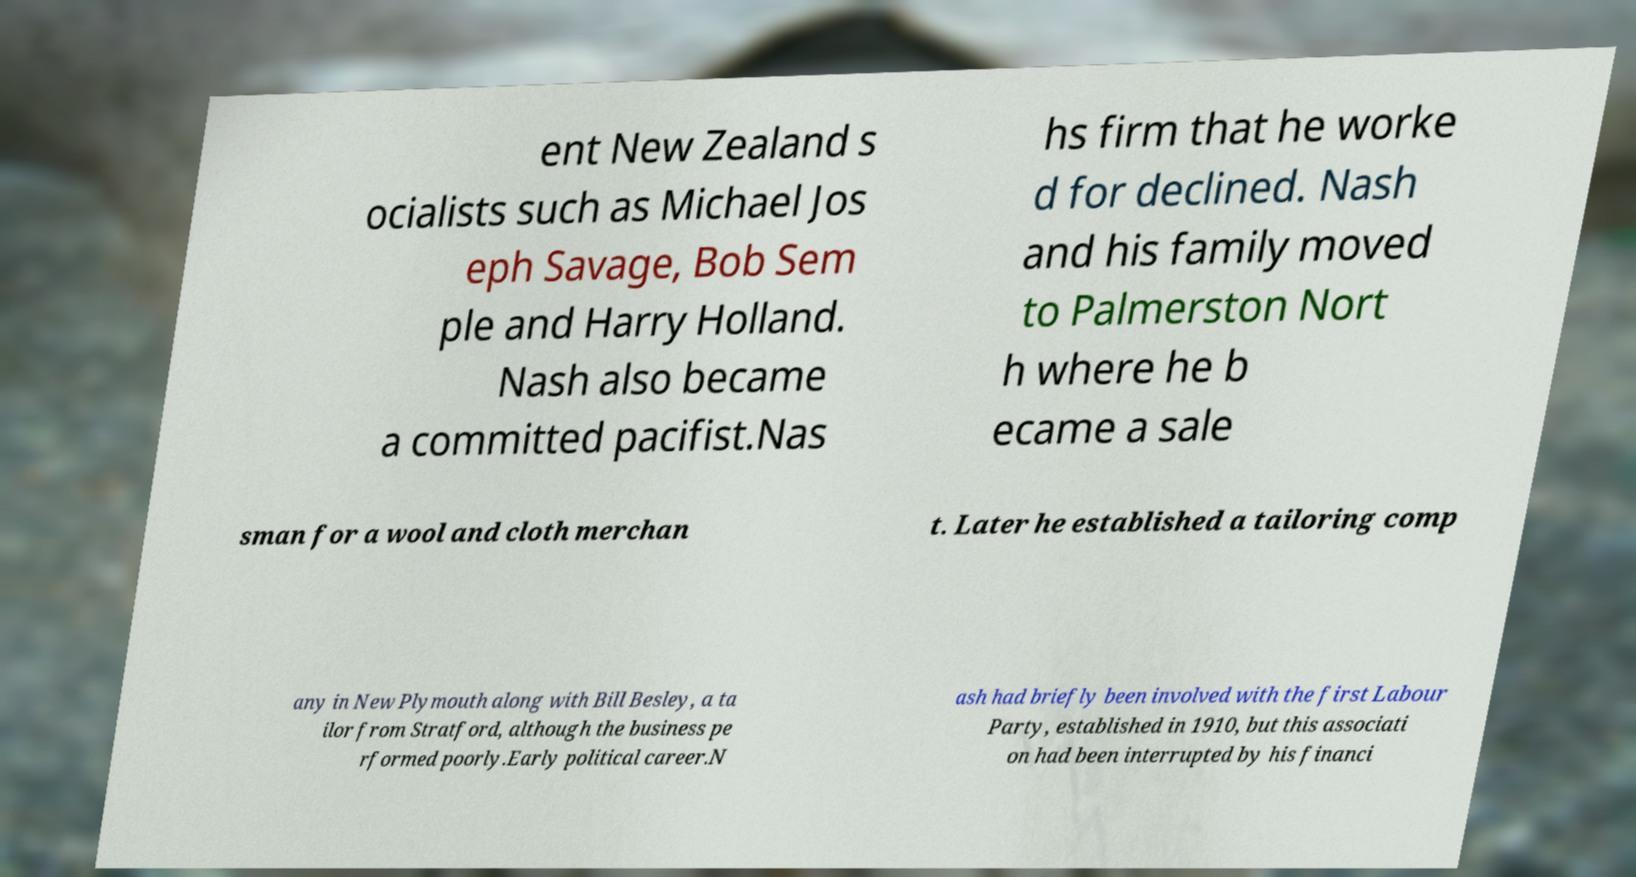Please read and relay the text visible in this image. What does it say? ent New Zealand s ocialists such as Michael Jos eph Savage, Bob Sem ple and Harry Holland. Nash also became a committed pacifist.Nas hs firm that he worke d for declined. Nash and his family moved to Palmerston Nort h where he b ecame a sale sman for a wool and cloth merchan t. Later he established a tailoring comp any in New Plymouth along with Bill Besley, a ta ilor from Stratford, although the business pe rformed poorly.Early political career.N ash had briefly been involved with the first Labour Party, established in 1910, but this associati on had been interrupted by his financi 